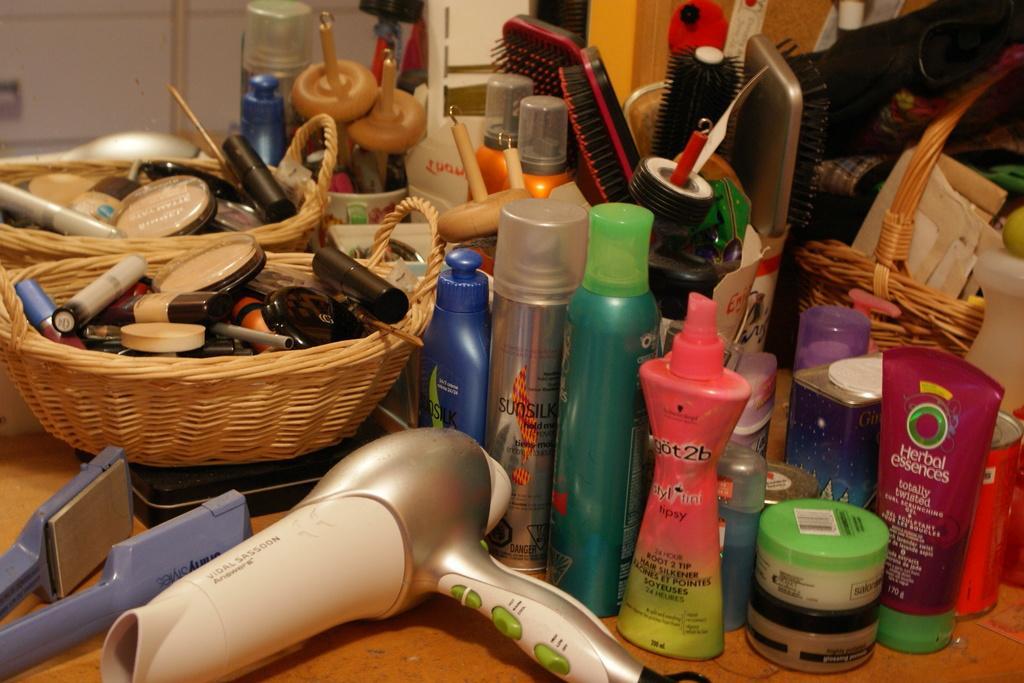<image>
Write a terse but informative summary of the picture. An untidy and very busy table is cluttered with brushes and bottles of Herbal Essences and Not2b amongst other make-up stuff. 